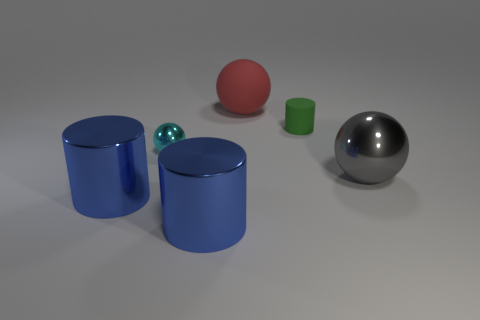Add 1 large blue cylinders. How many objects exist? 7 Subtract all large blue metallic things. Subtract all large gray objects. How many objects are left? 3 Add 4 red objects. How many red objects are left? 5 Add 5 big objects. How many big objects exist? 9 Subtract 0 blue balls. How many objects are left? 6 